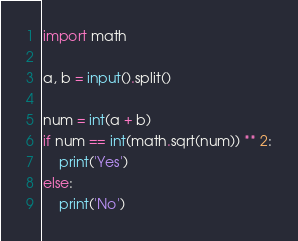Convert code to text. <code><loc_0><loc_0><loc_500><loc_500><_Python_>import math

a, b = input().split()

num = int(a + b)
if num == int(math.sqrt(num)) ** 2:
    print('Yes')
else:
    print('No')</code> 